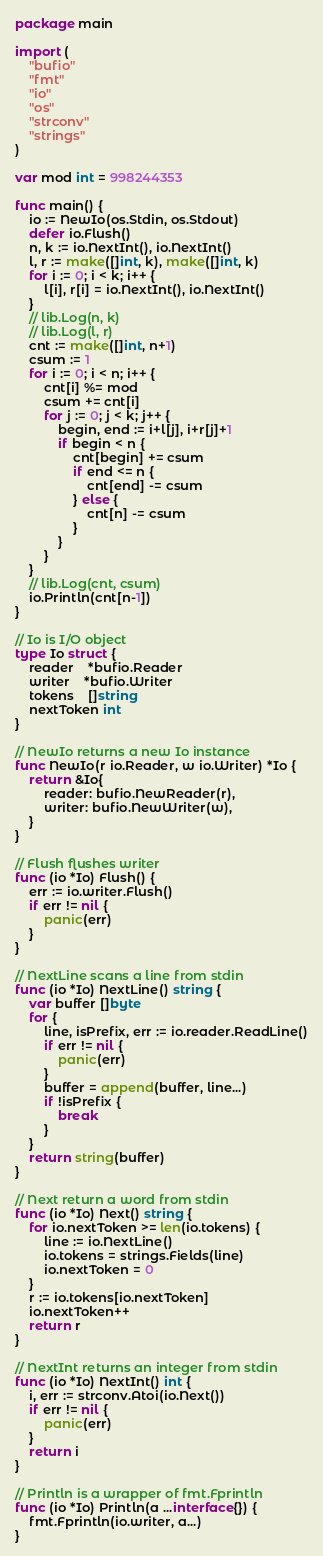<code> <loc_0><loc_0><loc_500><loc_500><_Go_>package main

import (
	"bufio"
	"fmt"
	"io"
	"os"
	"strconv"
	"strings"
)

var mod int = 998244353

func main() {
	io := NewIo(os.Stdin, os.Stdout)
	defer io.Flush()
	n, k := io.NextInt(), io.NextInt()
	l, r := make([]int, k), make([]int, k)
	for i := 0; i < k; i++ {
		l[i], r[i] = io.NextInt(), io.NextInt()
	}
	// lib.Log(n, k)
	// lib.Log(l, r)
	cnt := make([]int, n+1)
	csum := 1
	for i := 0; i < n; i++ {
		cnt[i] %= mod
		csum += cnt[i]
		for j := 0; j < k; j++ {
			begin, end := i+l[j], i+r[j]+1
			if begin < n {
				cnt[begin] += csum
				if end <= n {
					cnt[end] -= csum
				} else {
					cnt[n] -= csum
				}
			}
		}
	}
	// lib.Log(cnt, csum)
	io.Println(cnt[n-1])
}

// Io is I/O object
type Io struct {
	reader    *bufio.Reader
	writer    *bufio.Writer
	tokens    []string
	nextToken int
}

// NewIo returns a new Io instance
func NewIo(r io.Reader, w io.Writer) *Io {
	return &Io{
		reader: bufio.NewReader(r),
		writer: bufio.NewWriter(w),
	}
}

// Flush flushes writer
func (io *Io) Flush() {
	err := io.writer.Flush()
	if err != nil {
		panic(err)
	}
}

// NextLine scans a line from stdin
func (io *Io) NextLine() string {
	var buffer []byte
	for {
		line, isPrefix, err := io.reader.ReadLine()
		if err != nil {
			panic(err)
		}
		buffer = append(buffer, line...)
		if !isPrefix {
			break
		}
	}
	return string(buffer)
}

// Next return a word from stdin
func (io *Io) Next() string {
	for io.nextToken >= len(io.tokens) {
		line := io.NextLine()
		io.tokens = strings.Fields(line)
		io.nextToken = 0
	}
	r := io.tokens[io.nextToken]
	io.nextToken++
	return r
}

// NextInt returns an integer from stdin
func (io *Io) NextInt() int {
	i, err := strconv.Atoi(io.Next())
	if err != nil {
		panic(err)
	}
	return i
}

// Println is a wrapper of fmt.Fprintln
func (io *Io) Println(a ...interface{}) {
	fmt.Fprintln(io.writer, a...)
}
</code> 